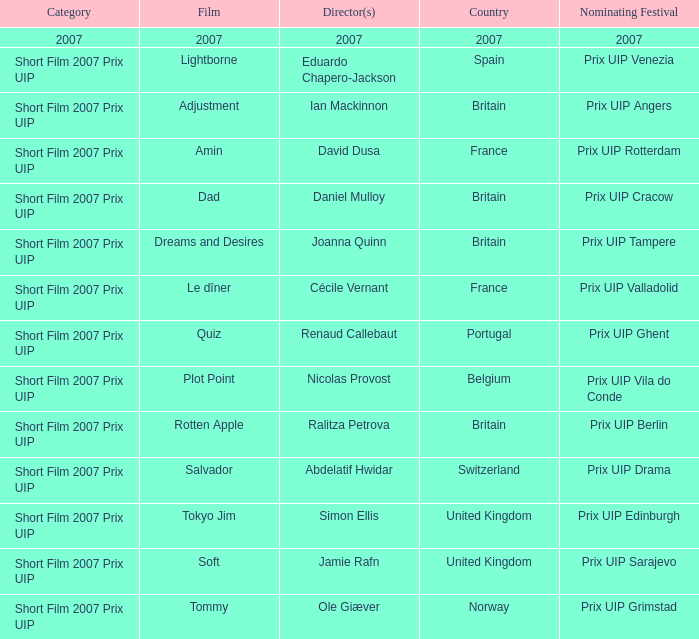What Nominating festival was party of the adjustment film? Prix UIP Angers. 